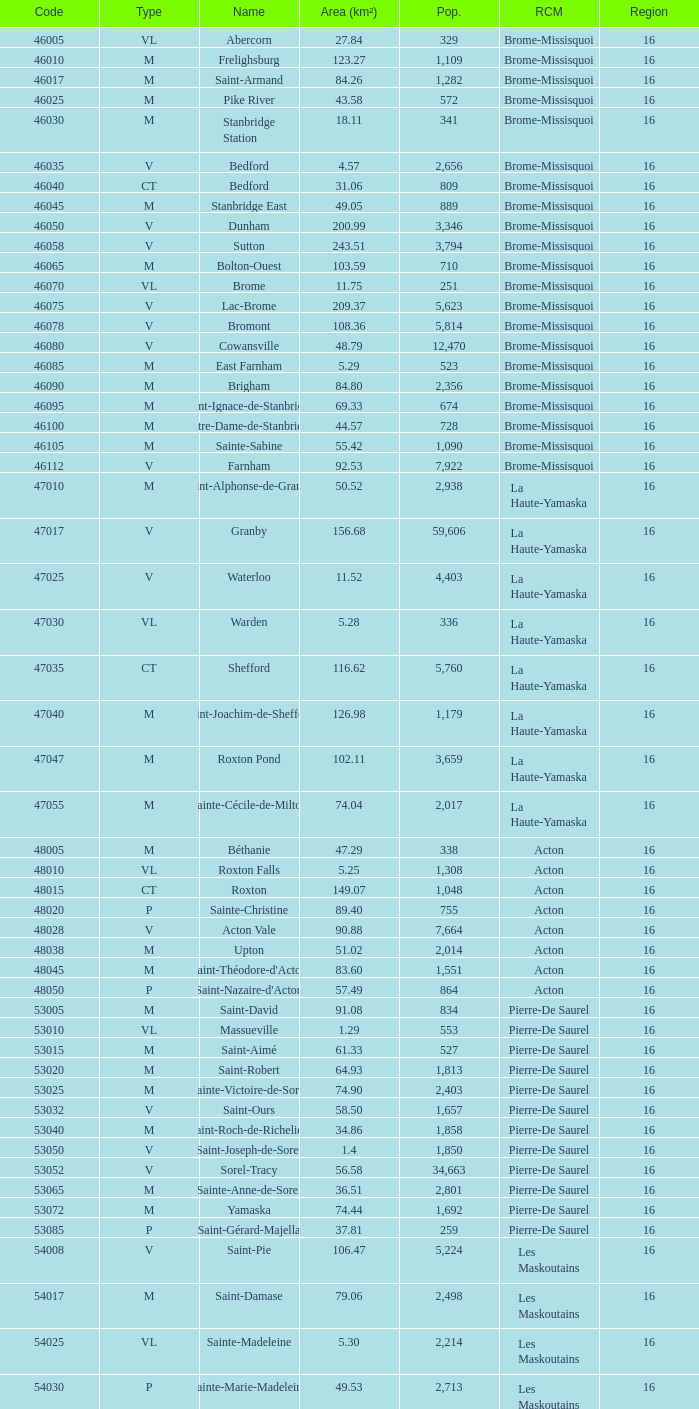What is the code for a Le Haut-Saint-Laurent municipality that has 16 or more regions? None. 